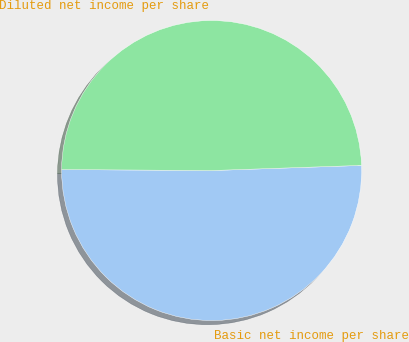Convert chart to OTSL. <chart><loc_0><loc_0><loc_500><loc_500><pie_chart><fcel>Basic net income per share<fcel>Diluted net income per share<nl><fcel>50.65%<fcel>49.35%<nl></chart> 